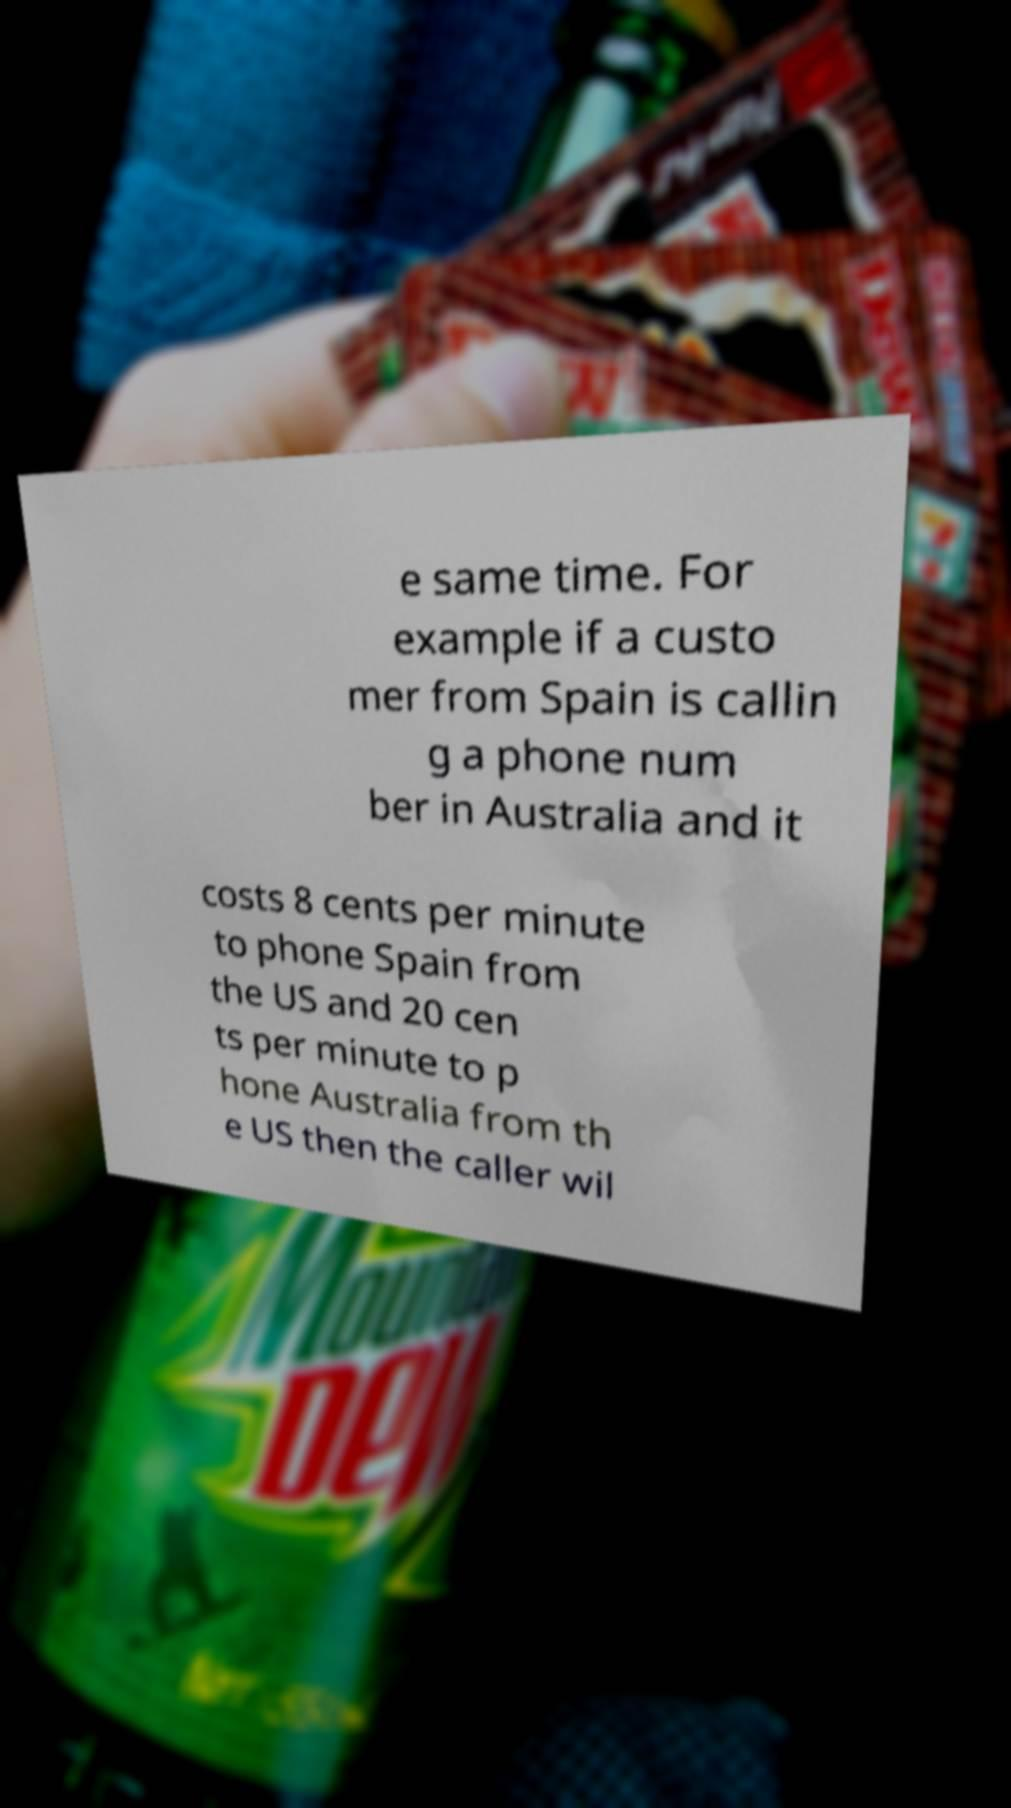For documentation purposes, I need the text within this image transcribed. Could you provide that? e same time. For example if a custo mer from Spain is callin g a phone num ber in Australia and it costs 8 cents per minute to phone Spain from the US and 20 cen ts per minute to p hone Australia from th e US then the caller wil 